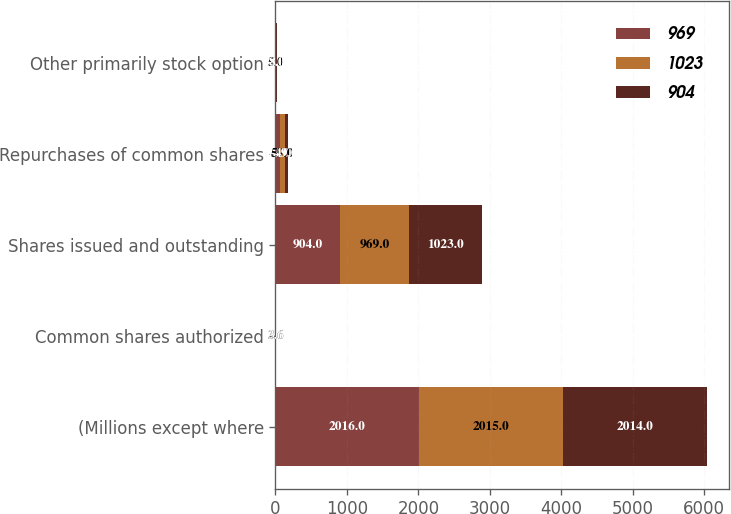Convert chart. <chart><loc_0><loc_0><loc_500><loc_500><stacked_bar_chart><ecel><fcel>(Millions except where<fcel>Common shares authorized<fcel>Shares issued and outstanding<fcel>Repurchases of common shares<fcel>Other primarily stock option<nl><fcel>969<fcel>2016<fcel>3.6<fcel>904<fcel>70<fcel>5<nl><fcel>1023<fcel>2015<fcel>3.6<fcel>969<fcel>59<fcel>5<nl><fcel>904<fcel>2014<fcel>3.6<fcel>1023<fcel>49<fcel>8<nl></chart> 